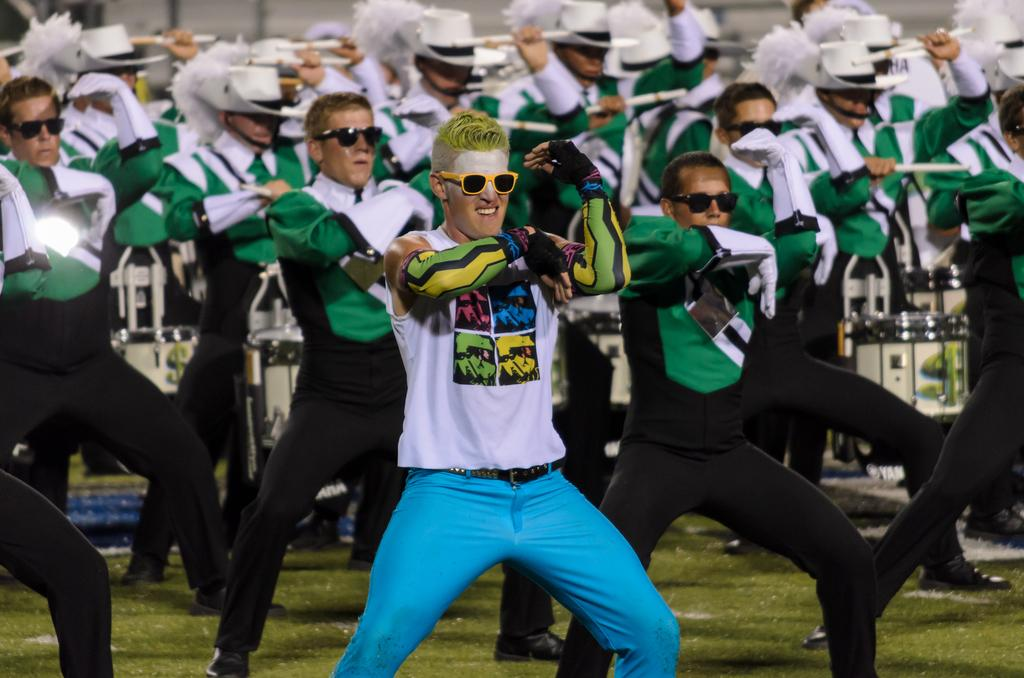What is happening in the image? There are many people dancing in the image. Can you describe the man in the front? The man in the front is wearing a white T-shirt and blue pants. What are the people in the background wearing? In the background, all people are wearing green shirts and black pants. What type of pet can be seen in the image? There is no pet visible in the image; it features people dancing. Can you tell me how many faces are hidden behind the waste in the image? There is no waste present in the image, and therefore no faces can be hidden behind it. 